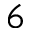<formula> <loc_0><loc_0><loc_500><loc_500>^ { 6 }</formula> 